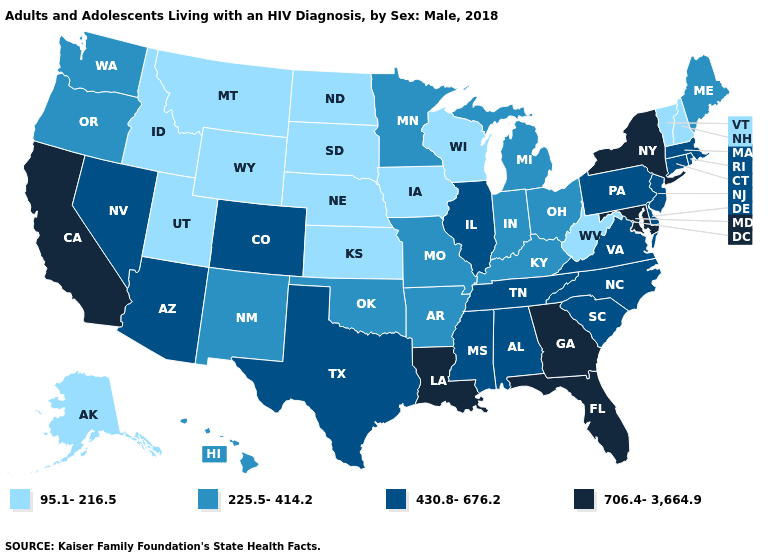Does the map have missing data?
Quick response, please. No. Is the legend a continuous bar?
Keep it brief. No. How many symbols are there in the legend?
Keep it brief. 4. Name the states that have a value in the range 430.8-676.2?
Be succinct. Alabama, Arizona, Colorado, Connecticut, Delaware, Illinois, Massachusetts, Mississippi, Nevada, New Jersey, North Carolina, Pennsylvania, Rhode Island, South Carolina, Tennessee, Texas, Virginia. Name the states that have a value in the range 225.5-414.2?
Concise answer only. Arkansas, Hawaii, Indiana, Kentucky, Maine, Michigan, Minnesota, Missouri, New Mexico, Ohio, Oklahoma, Oregon, Washington. Name the states that have a value in the range 225.5-414.2?
Keep it brief. Arkansas, Hawaii, Indiana, Kentucky, Maine, Michigan, Minnesota, Missouri, New Mexico, Ohio, Oklahoma, Oregon, Washington. What is the value of Louisiana?
Be succinct. 706.4-3,664.9. What is the lowest value in states that border Montana?
Keep it brief. 95.1-216.5. What is the value of Connecticut?
Short answer required. 430.8-676.2. What is the highest value in the MidWest ?
Concise answer only. 430.8-676.2. What is the value of Illinois?
Keep it brief. 430.8-676.2. What is the highest value in the USA?
Answer briefly. 706.4-3,664.9. Name the states that have a value in the range 430.8-676.2?
Answer briefly. Alabama, Arizona, Colorado, Connecticut, Delaware, Illinois, Massachusetts, Mississippi, Nevada, New Jersey, North Carolina, Pennsylvania, Rhode Island, South Carolina, Tennessee, Texas, Virginia. What is the value of Colorado?
Answer briefly. 430.8-676.2. 